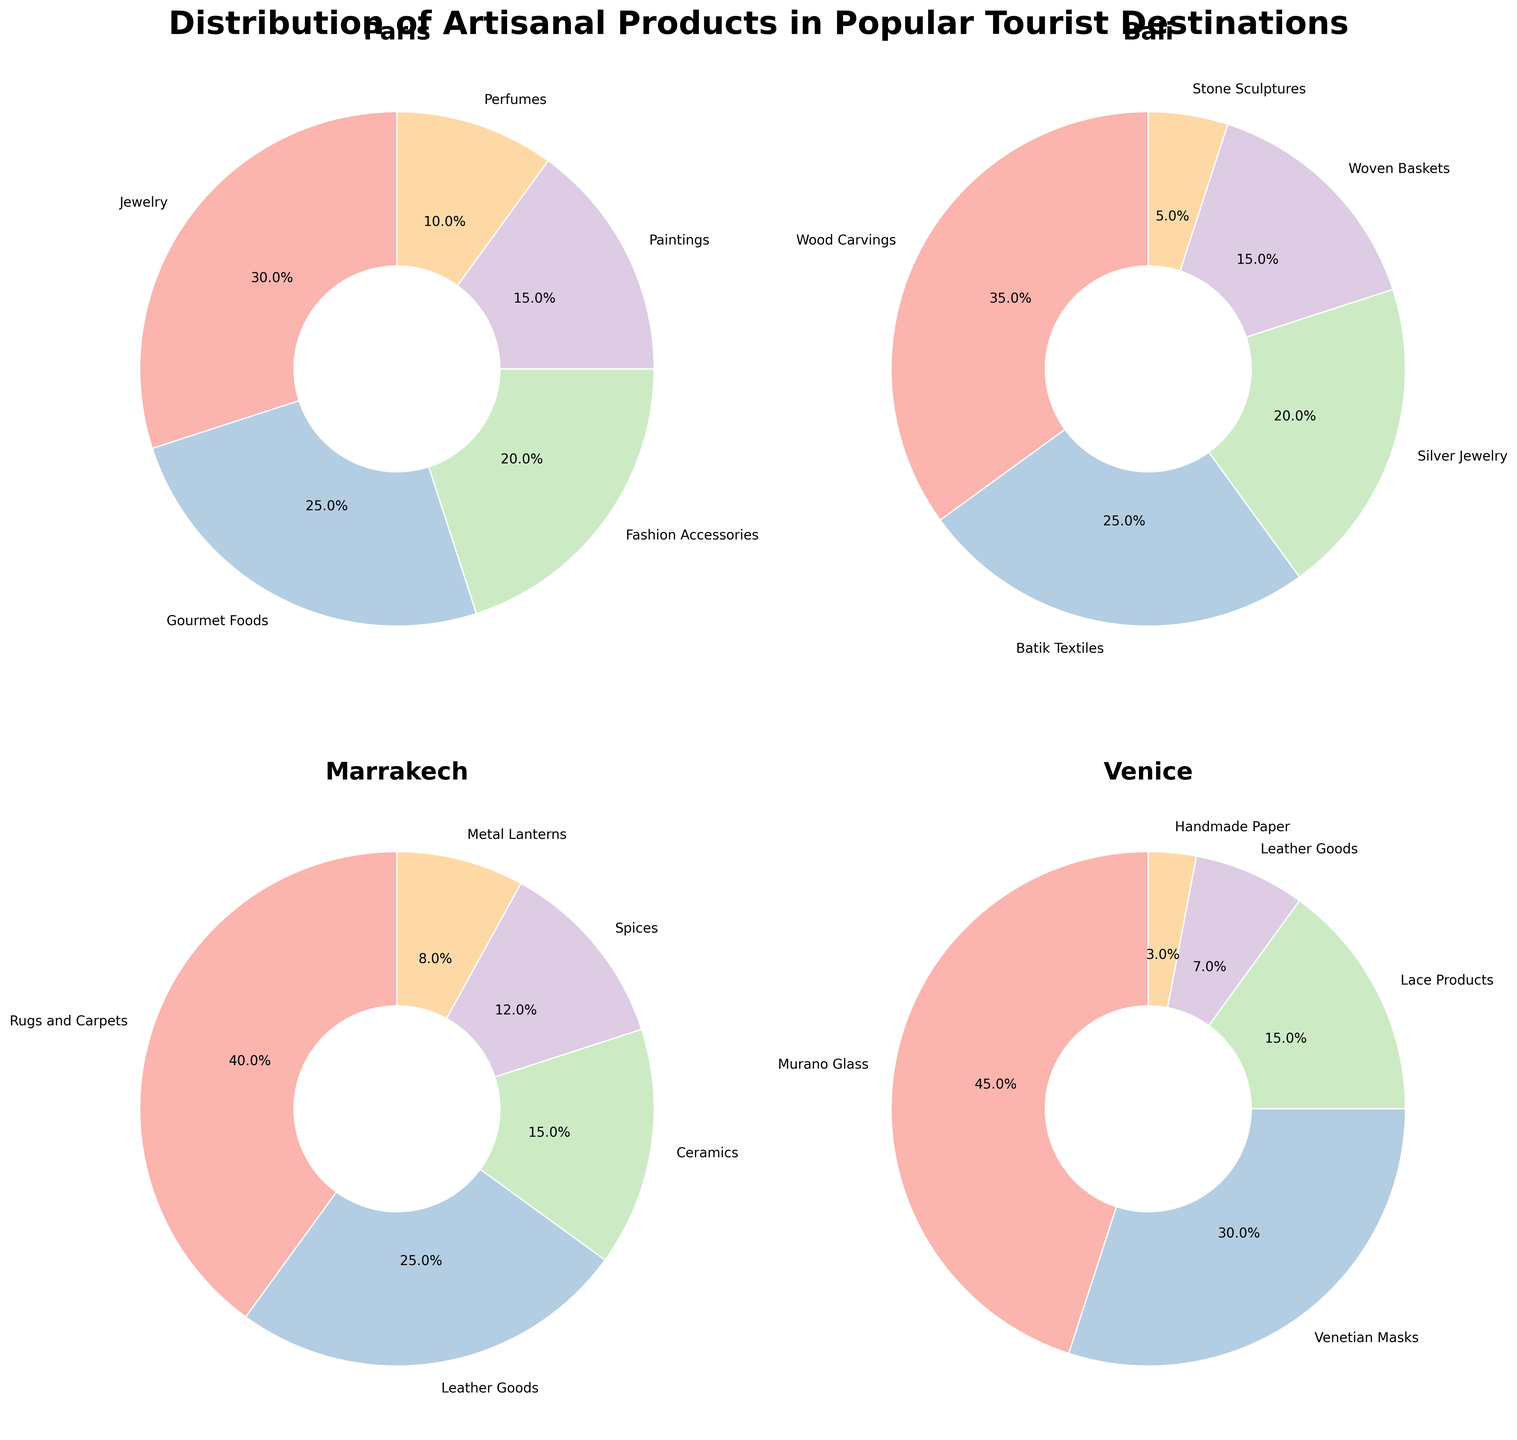What percentage of artisanal products in Venice are Murano Glass? To find this, locate the pie chart for Venice. Observe the sector labeled Murano Glass and its corresponding percentage.
Answer: 45% Which destination has the highest percentage of a single artisanal product type, and what is it? Identify the sectors with the highest individual percentages within each pie chart. Compare these percentages to find the largest one.
Answer: Marrakech, Rugs and Carpets with 40% What is the combined percentage of jewelry-related products in Paris and Bali? Add the percentage of Jewelry in Paris (30%) to the percentage of Silver Jewelry in Bali (20%).
Answer: 50% Which destination offers the widest variety of artisanal products? Count the number of distinct artisanal product types for each destination in the subplot.
Answer: Paris How much higher is the percentage of Venetian Masks in Venice compared to Leather Goods? Subtract the percentage of Leather Goods (7%) from Venetian Masks (30%) in the Venice pie chart.
Answer: 23% What portion of Marrakech's artisanal products are non-textile items? Sum the percentages of Ceramics (15%), Spices (12%), and Metal Lanterns (8%) in the Marrakech pie chart.
Answer: 35% What are the top two artisanal products by percentage in Bali? Identify the two largest sectors in Bali's pie chart and note their percentages.
Answer: Wood Carvings with 35% and Batik Textiles with 25% How does the percentage of Perfumes in Paris compare to the percentage of Handmade Paper in Venice? Locate the sectors labeled Perfumes and Handmade Paper in their respective pie charts and compare their percentages.
Answer: Perfumes in Paris are higher (10% vs. 3%) Which destination has the smallest category among all, and what is the product type? Analyze each pie chart to identify and compare the smallest sectors by percentage.
Answer: Venice, Handmade Paper with 3% If you combine all the percentages of gourmet food-related products across all destinations, what would it be? Sum the percentages of all products related to gourmet foods: Gourmet Foods in Paris (25%) and Spices in Marrakech (12%).
Answer: 37% 